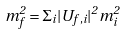Convert formula to latex. <formula><loc_0><loc_0><loc_500><loc_500>m ^ { 2 } _ { f } = \Sigma _ { i } | U _ { f , i } | ^ { 2 } m ^ { 2 } _ { i }</formula> 